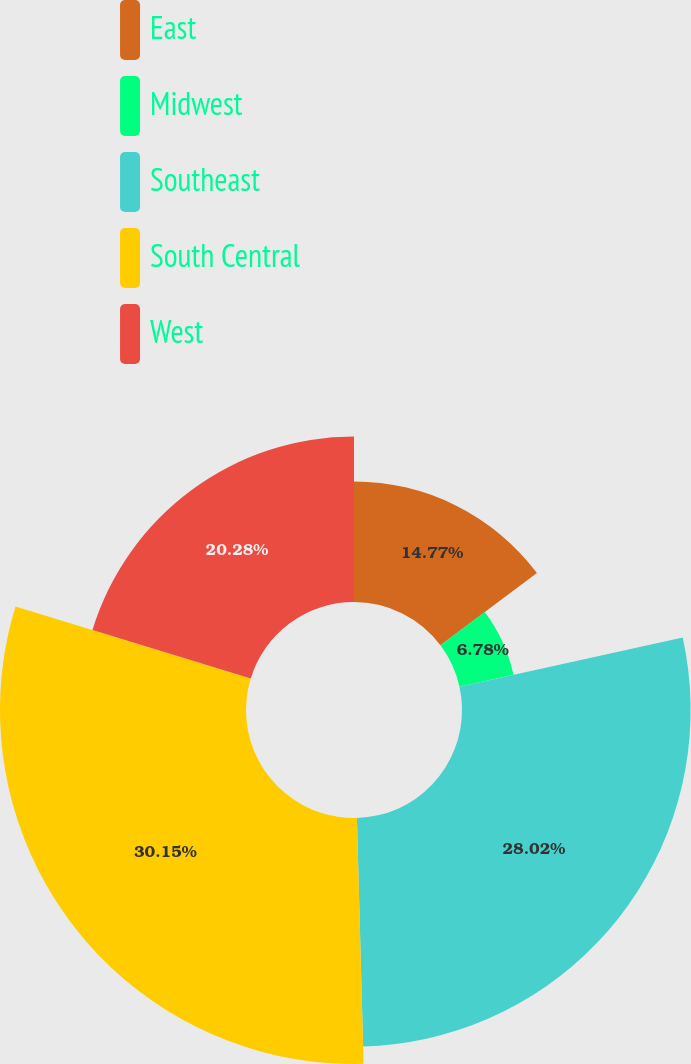<chart> <loc_0><loc_0><loc_500><loc_500><pie_chart><fcel>East<fcel>Midwest<fcel>Southeast<fcel>South Central<fcel>West<nl><fcel>14.77%<fcel>6.78%<fcel>28.02%<fcel>30.15%<fcel>20.28%<nl></chart> 